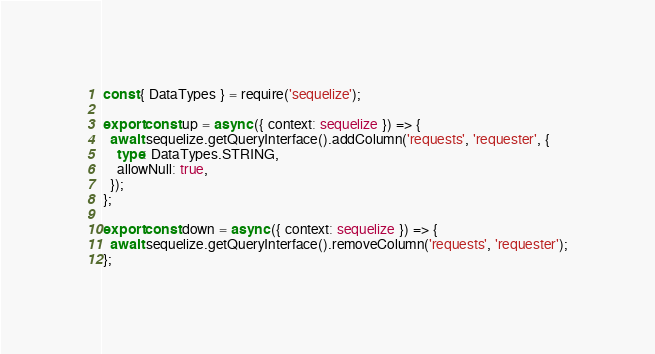<code> <loc_0><loc_0><loc_500><loc_500><_TypeScript_>const { DataTypes } = require('sequelize');

export const up = async ({ context: sequelize }) => {
  await sequelize.getQueryInterface().addColumn('requests', 'requester', {
    type: DataTypes.STRING,
    allowNull: true,
  });
};

export const down = async ({ context: sequelize }) => {
  await sequelize.getQueryInterface().removeColumn('requests', 'requester');
};
</code> 